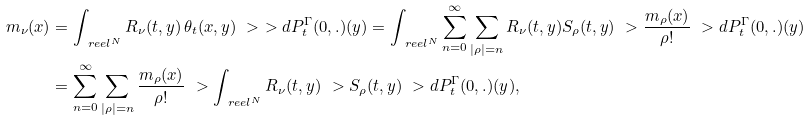<formula> <loc_0><loc_0><loc_500><loc_500>m _ { \nu } ( x ) & = \int _ { \ r e e l ^ { N } } R _ { \nu } ( t , y ) \, \theta _ { t } ( x , y ) \ > \ > d P _ { t } ^ { \Gamma } ( 0 , . ) ( y ) = \int _ { \ r e e l ^ { N } } \sum _ { n = 0 } ^ { \infty } \sum _ { | \rho | = n } R _ { \nu } ( t , y ) S _ { \rho } ( t , y ) \ > \frac { m _ { \rho } ( x ) } { \rho ! } \ > d P _ { t } ^ { \Gamma } ( 0 , . ) ( y ) \\ & = \sum _ { n = 0 } ^ { \infty } \sum _ { | \rho | = n } \frac { m _ { \rho } ( x ) } { \rho ! } \ > \int _ { \ r e e l ^ { N } } R _ { \nu } ( t , y ) \ > S _ { \rho } ( t , y ) \ > d P _ { t } ^ { \Gamma } ( 0 , . ) ( y ) ,</formula> 